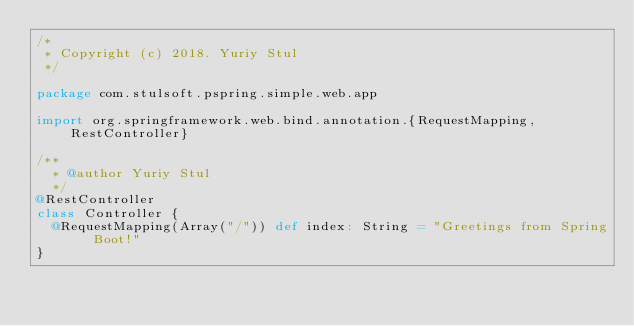<code> <loc_0><loc_0><loc_500><loc_500><_Scala_>/*
 * Copyright (c) 2018. Yuriy Stul
 */

package com.stulsoft.pspring.simple.web.app

import org.springframework.web.bind.annotation.{RequestMapping, RestController}

/**
  * @author Yuriy Stul
  */
@RestController
class Controller {
  @RequestMapping(Array("/")) def index: String = "Greetings from Spring Boot!"
}
</code> 